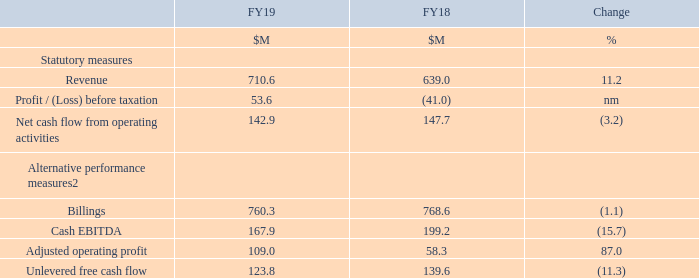The Group made an operating profit of $60.9 million in the year and adjusted operating profit increased by $50.7 million to $109.0 million, primarily as a result of strong revenue growth. This year's result benefited from a foreign exchange gain of $1.5 million, compared to a foreign exchange loss of $6.9 million in the prior-year.
The Group’s profit before taxation increased by $94.6 million to $53.6 million, from a loss of $41.0 million in the prior-year, primarily as a consequence of the $80.6 million improvement in operating profit supported by a $13.4 million reduction in finance expenses. Finance expenses benefited from foreign exchange gains in the current year resulting from the strengthening of both sterling and the euro against the US dollar, compared to foreign exchange losses in the prior-year.
The Group’s profit for the year increased by $87.8 million to $26.9 million in the year-ended 31 March 2019, which given only a small increase in the year-on-year income tax charge was primarily attributable to the improvement in the profit before taxation.
Cash flow from operating activities remained strong at $142.9 million, reduced by $4.8 million from $147.7 million in the prior-year. The small overall decrease was due to an increase in overheads, partially offset by a reduction in the cashflow outflow on exceptional items and an improved use of working capital. Unlevered free cashflow decreased by $15.8 million to $123.8 million representing the reduction in net cash flow from operating activities adjusted for the cashflow impact of exceptional items.
The table below presents the Group’s financial highlights on a reported basis:
1 Restated for the adoption of IFRS 15 and change in accounting policy in respect of research and development expenditure tax credit scheme and provision for interest on uncertain tax positions, as explained in note 2 of the Financial Statements
2 Definitions and reconciliations of non-GAAP measures are included in note 5 of the Financial Statements
What are the values for FY18 restated for? Restated for the adoption of ifrs 15 and change in accounting policy in respect of research and development expenditure tax credit scheme and provision for interest on uncertain tax positions, as explained in note 2 of the financial statements. Where can the definitions and reconciliations for non-GAAP measures under alternative performance measures be found? In note 5 of the financial statements. What are the components under Statutory measures in the table? Revenue, profit / (loss) before taxation, net cash flow from operating activities. In which year was Billings larger? 768.6>760.3
Answer: fy18. What was the change in Revenue in 2019 from 2018?
Answer scale should be: million. 710.6-639.0
Answer: 71.6. What was the average revenue in 2018 and 2019?
Answer scale should be: million. (710.6+639.0)/2
Answer: 674.8. 